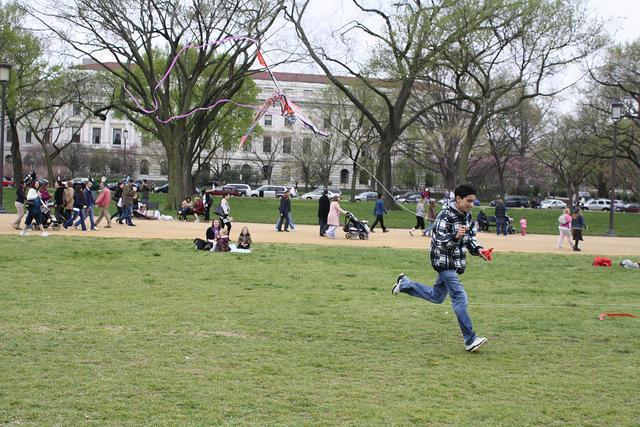How many people are there?
Give a very brief answer. 2. How many numbers are on the clock tower?
Give a very brief answer. 0. 